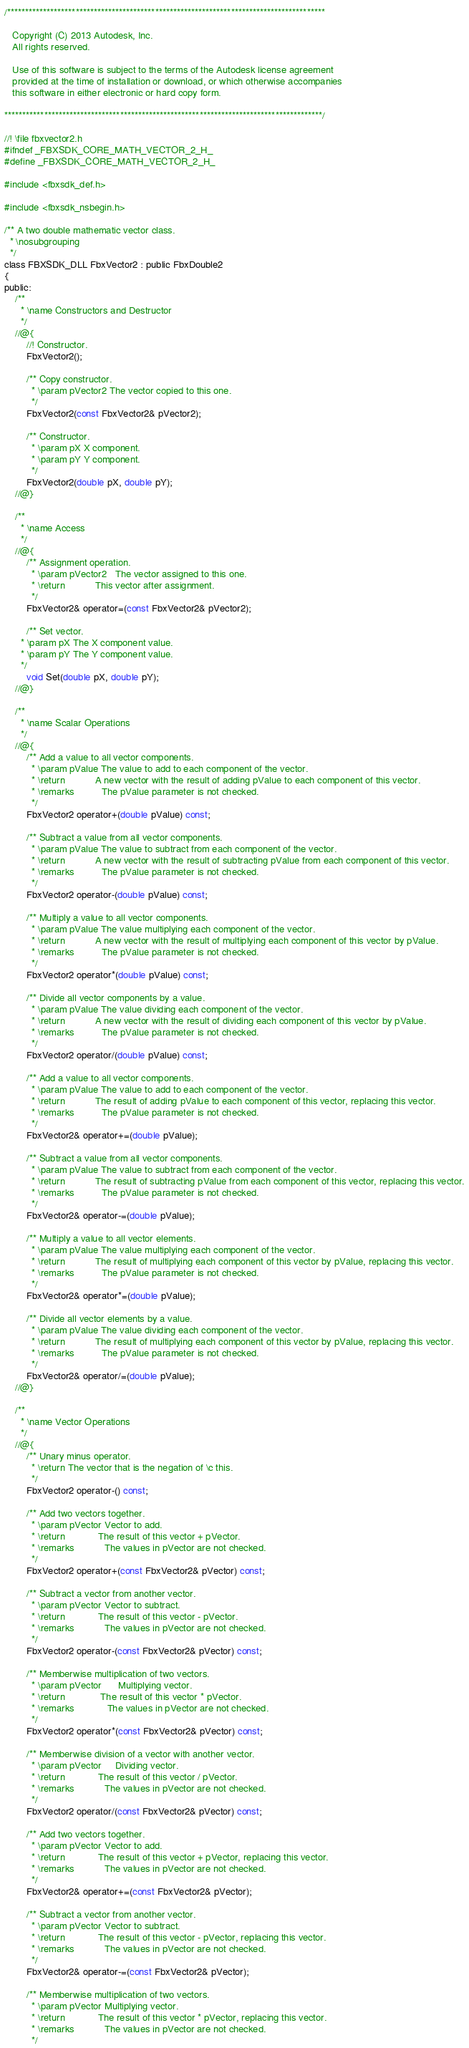Convert code to text. <code><loc_0><loc_0><loc_500><loc_500><_C_>/****************************************************************************************
 
   Copyright (C) 2013 Autodesk, Inc.
   All rights reserved.
 
   Use of this software is subject to the terms of the Autodesk license agreement
   provided at the time of installation or download, or which otherwise accompanies
   this software in either electronic or hard copy form.
 
****************************************************************************************/

//! \file fbxvector2.h
#ifndef _FBXSDK_CORE_MATH_VECTOR_2_H_
#define _FBXSDK_CORE_MATH_VECTOR_2_H_

#include <fbxsdk_def.h>

#include <fbxsdk_nsbegin.h>

/**	A two double mathematic vector class.
  * \nosubgrouping
  */
class FBXSDK_DLL FbxVector2 : public FbxDouble2
{
public:
	/**
	  * \name Constructors and Destructor
	  */
	//@{
		//! Constructor.
		FbxVector2();

		/** Copy constructor.
		  * \param pVector2 The vector copied to this one.
		  */
		FbxVector2(const FbxVector2& pVector2);

		/** Constructor.
		  *	\param pX X component.
		  *	\param pY Y component.
		  */
		FbxVector2(double pX, double pY);
	//@}

	/**
	  * \name Access
	  */
	//@{
		/** Assignment operation.
		  * \param pVector2   The vector assigned to this one.
		  * \return           This vector after assignment. 
		  */
		FbxVector2& operator=(const FbxVector2& pVector2);

		/** Set vector.
	  * \param pX The X component value.
	  * \param pY The Y component value.
	  */
		void Set(double pX, double pY);
	//@}

	/**
	  * \name Scalar Operations
	  */
	//@{
		/** Add a value to all vector components.
		  * \param pValue The value to add to each component of the vector.
		  * \return           A new vector with the result of adding pValue to each component of this vector.
		  * \remarks          The pValue parameter is not checked.
		  */
		FbxVector2 operator+(double pValue) const;

		/** Subtract a value from all vector components.
		  * \param pValue The value to subtract from each component of the vector.
		  * \return           A new vector with the result of subtracting pValue from each component of this vector.
		  * \remarks          The pValue parameter is not checked.
		  */
		FbxVector2 operator-(double pValue) const;

		/** Multiply a value to all vector components.
		  * \param pValue The value multiplying each component of the vector.
		  * \return           A new vector with the result of multiplying each component of this vector by pValue.
		  * \remarks          The pValue parameter is not checked.
		  */
		FbxVector2 operator*(double pValue) const;

		/**	Divide all vector components by a value.
		  * \param pValue The value dividing each component of the vector.
		  * \return           A new vector with the result of dividing each component of this vector by pValue.
		  * \remarks          The pValue parameter is not checked.
		  */
		FbxVector2 operator/(double pValue) const;

		/** Add a value to all vector components.
		  * \param pValue The value to add to each component of the vector.
		  * \return           The result of adding pValue to each component of this vector, replacing this vector.
		  * \remarks          The pValue parameter is not checked.
		  */
		FbxVector2& operator+=(double pValue);

		/** Subtract a value from all vector components.
		  * \param pValue The value to subtract from each component of the vector.
		  * \return           The result of subtracting pValue from each component of this vector, replacing this vector.
		  * \remarks          The pValue parameter is not checked.
		  */
		FbxVector2& operator-=(double pValue);

		/** Multiply a value to all vector elements.
		  * \param pValue The value multiplying each component of the vector.
		  * \return           The result of multiplying each component of this vector by pValue, replacing this vector.
		  * \remarks          The pValue parameter is not checked.
		  */
		FbxVector2& operator*=(double pValue);

		/**	Divide all vector elements by a value.
		  * \param pValue The value dividing each component of the vector.
		  * \return           The result of multiplying each component of this vector by pValue, replacing this vector.
		  * \remarks          The pValue parameter is not checked.
		  */
		FbxVector2& operator/=(double pValue);
	//@}

	/**
	  * \name Vector Operations
	  */
	//@{
		/**	Unary minus operator.
		  * \return The vector that is the negation of \c this.
		  */
		FbxVector2 operator-() const;

		/** Add two vectors together.
		  * \param pVector Vector to add.
		  * \return            The result of this vector + pVector.
		  * \remarks           The values in pVector are not checked.
		  */
		FbxVector2 operator+(const FbxVector2& pVector) const;

		/** Subtract a vector from another vector.
		  * \param pVector Vector to subtract.
		  * \return            The result of this vector - pVector.
		  * \remarks           The values in pVector are not checked.
		  */
		FbxVector2 operator-(const FbxVector2& pVector) const;

		/** Memberwise multiplication of two vectors.
		  * \param pVector      Multiplying vector.
		  * \return             The result of this vector * pVector.
		  * \remarks            The values in pVector are not checked.
		  */
		FbxVector2 operator*(const FbxVector2& pVector) const;

		/** Memberwise division of a vector with another vector.
		  * \param pVector     Dividing vector.
		  * \return            The result of this vector / pVector.
		  * \remarks           The values in pVector are not checked.
		  */
		FbxVector2 operator/(const FbxVector2& pVector) const;

		/** Add two vectors together.
		  * \param pVector Vector to add.
		  * \return            The result of this vector + pVector, replacing this vector.
		  * \remarks           The values in pVector are not checked.
		  */
		FbxVector2& operator+=(const FbxVector2& pVector);

		/** Subtract a vector from another vector.
		  * \param pVector Vector to subtract.
		  * \return            The result of this vector - pVector, replacing this vector.
		  * \remarks           The values in pVector are not checked.
		  */
		FbxVector2& operator-=(const FbxVector2& pVector);

		/** Memberwise multiplication of two vectors.
		  * \param pVector Multiplying vector.
		  * \return            The result of this vector * pVector, replacing this vector.
		  * \remarks           The values in pVector are not checked.
		  */</code> 